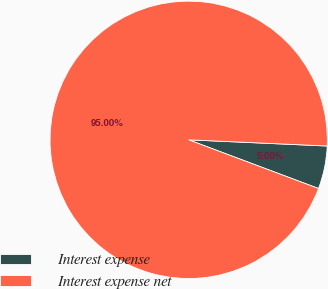Convert chart. <chart><loc_0><loc_0><loc_500><loc_500><pie_chart><fcel>Interest expense<fcel>Interest expense net<nl><fcel>5.0%<fcel>95.0%<nl></chart> 